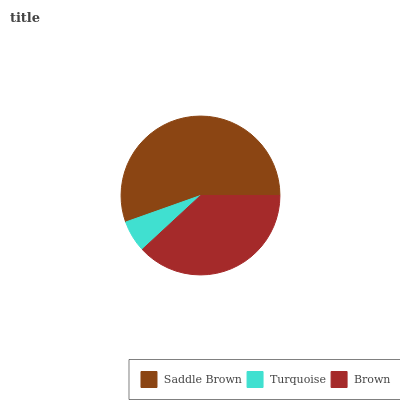Is Turquoise the minimum?
Answer yes or no. Yes. Is Saddle Brown the maximum?
Answer yes or no. Yes. Is Brown the minimum?
Answer yes or no. No. Is Brown the maximum?
Answer yes or no. No. Is Brown greater than Turquoise?
Answer yes or no. Yes. Is Turquoise less than Brown?
Answer yes or no. Yes. Is Turquoise greater than Brown?
Answer yes or no. No. Is Brown less than Turquoise?
Answer yes or no. No. Is Brown the high median?
Answer yes or no. Yes. Is Brown the low median?
Answer yes or no. Yes. Is Turquoise the high median?
Answer yes or no. No. Is Turquoise the low median?
Answer yes or no. No. 